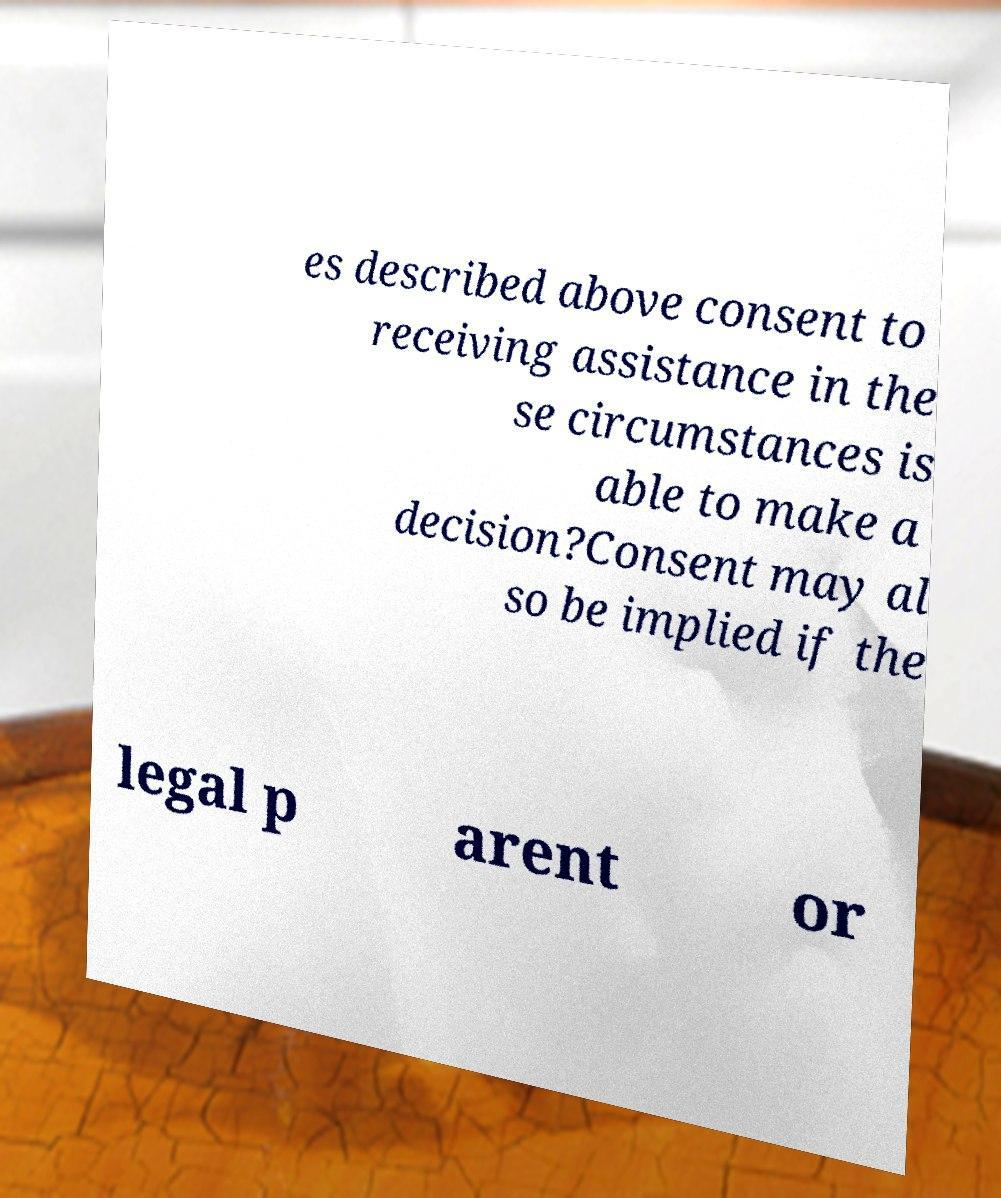There's text embedded in this image that I need extracted. Can you transcribe it verbatim? es described above consent to receiving assistance in the se circumstances is able to make a decision?Consent may al so be implied if the legal p arent or 